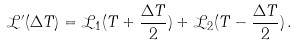<formula> <loc_0><loc_0><loc_500><loc_500>\mathcal { L ^ { \prime } } ( \Delta T ) = \mathcal { L } _ { 1 } ( T + \frac { \Delta T } { 2 } ) + \mathcal { L } _ { 2 } ( T - \frac { \Delta T } { 2 } ) \, .</formula> 